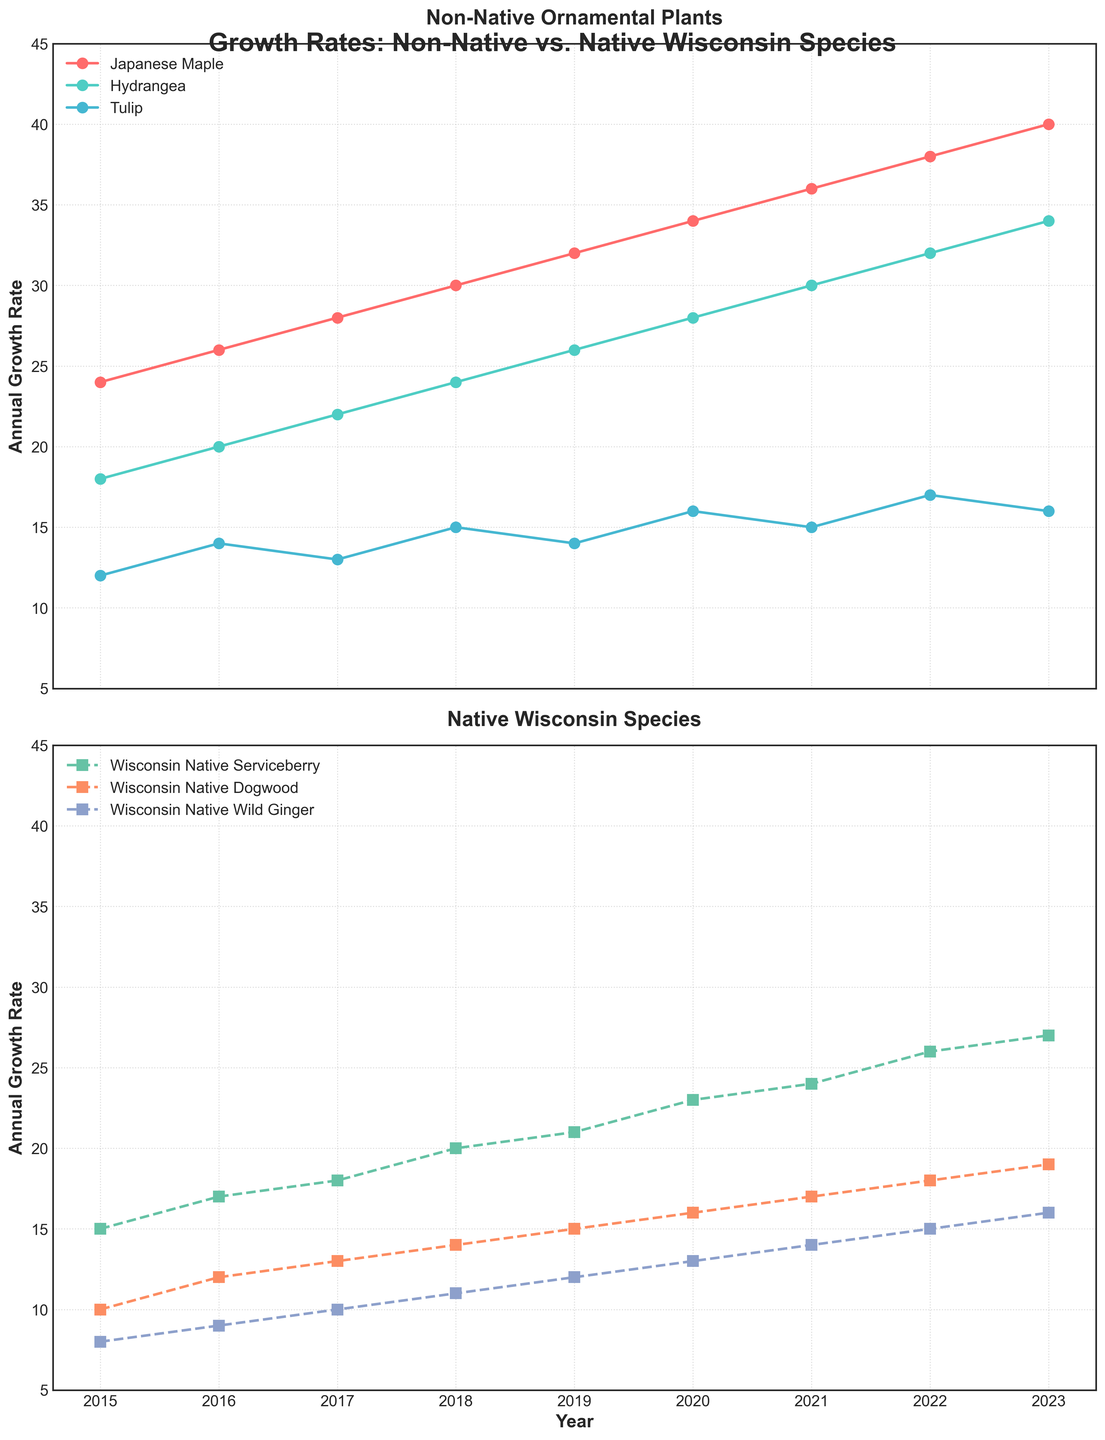What's the overall trend for Japanese Maple over the years? Observing the line representing Japanese Maple in the top plot, it shows a clear upward trend from 2015 to 2023. The growth rate increases steadily each year from 24 to 40.
Answer: Upward trend How does the growth rate of Hydrangea in 2020 compare to the growth rate of Wisconsin Native Dogwood in the same year? In 2020, the growth rate for Hydrangea is 28, and for Wisconsin Native Dogwood, it is 16. By comparing these two values, Hydrangea's growth rate is higher.
Answer: Hydrangea's rate is higher What is the average growth rate of Wisconsin Native Wild Ginger over the 9-year period? Summing the annual growth rates of Wisconsin Native Wild Ginger from 2015 to 2023 (8 + 9 + 10 + 11 + 12 + 13 + 14 + 15 + 16) equals 108. Dividing this total by 9 years gives an average of 108 / 9 = 12.
Answer: 12 Which plant had the smallest increase in growth rate from 2019 to 2023? From the data, we see the change in growth rates from 2019 to 2023: Japanese Maple (40-32=8), Hydrangea (34-26=8), Tulip (16-14=2), Wisconsin Native Serviceberry (27-21=6), Wisconsin Native Dogwood (19-15=4), Wisconsin Native Wild Ginger (16-12=4). Tulip had the smallest increase.
Answer: Tulip What is the difference in the maximum growth rate between the non-native and native plants in 2023? The maximum growth rate in 2023 for non-native plants is Japanese Maple at 40, and for native plants, it is Wisconsin Native Serviceberry at 27. The difference is 40 - 27 = 13.
Answer: 13 How do the trends of Japanese Maple and Wisconsin Native Serviceberry compare from 2015 to 2023? Both Japanese Maple and Wisconsin Native Serviceberry show upward trends over the years. Japanese Maple has a steeper increase from 24 to 40, while Wisconsin Native Serviceberry goes from 15 to 27, indicating a more moderate increase. Both trends are positive, but Japanese Maple's growth rate increases more sharply.
Answer: Both trends are upward; Japanese Maple increases more steeply Which years did all the native Wisconsin species have a higher growth rate than Tulip? Comparing the values for each year: 
2015: (15, 10, 8 > 12) - No
2016: (17, 12, 9 > 14) - No
2017: (18, 13, 10 > 13) - No
2018: (20, 14, 11 > 15) - No
2019: (21, 15, 12 > 14) - Yes
2020: (23, 16, 13 > 16) - No
2021: (24, 17, 14 > 15) - Yes
2022: (26, 18, 15 > 17) - No
2023: (27, 19, 16 > 16) - Yes
Years 2019, 2021, and 2023 are when all native Wisconsin species had higher growth rates than Tulip.
Answer: 2019, 2021, 2023 